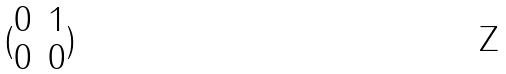Convert formula to latex. <formula><loc_0><loc_0><loc_500><loc_500>( \begin{matrix} 0 & 1 \\ 0 & 0 \end{matrix} )</formula> 